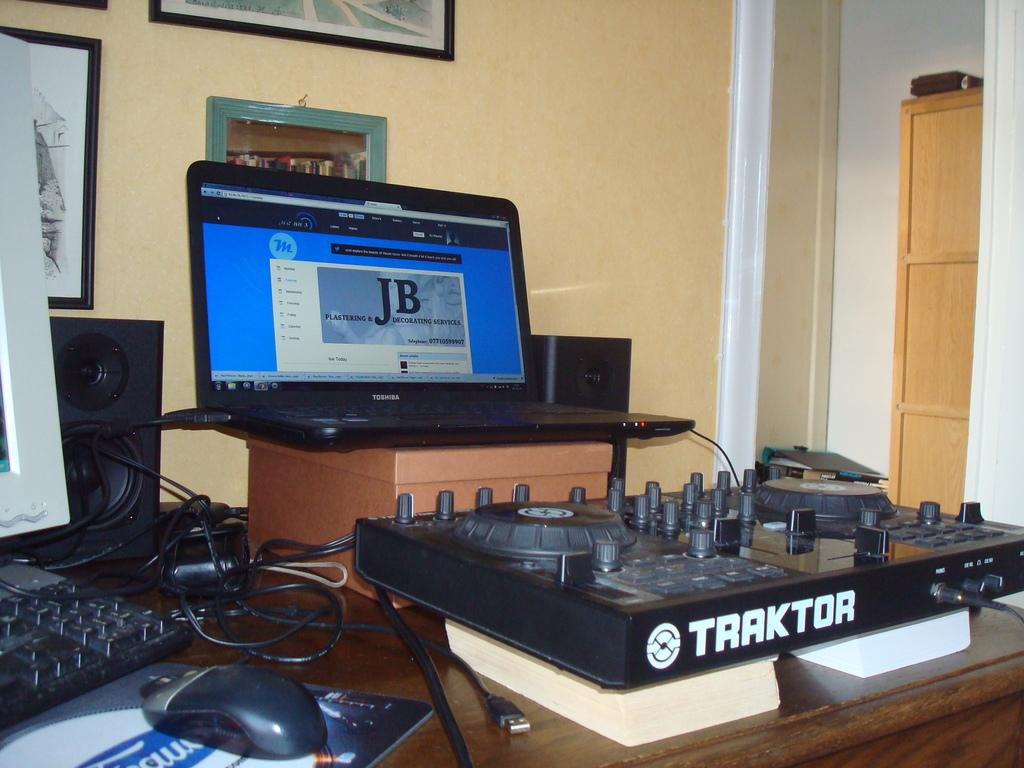<image>
Summarize the visual content of the image. Traktor sound system that is connected to the laptop and has the letters JB on the screen. 